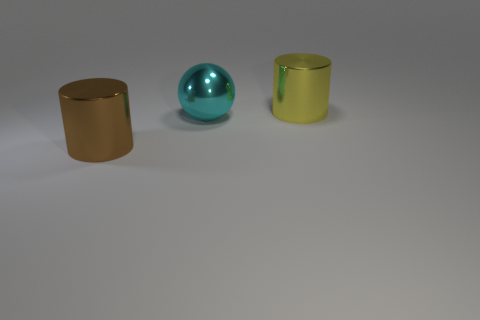How big is the object that is both to the left of the yellow metal object and behind the brown cylinder?
Provide a succinct answer. Large. What is the shape of the big cyan thing that is made of the same material as the brown cylinder?
Your response must be concise. Sphere. Are the big yellow thing and the object on the left side of the cyan metallic ball made of the same material?
Provide a succinct answer. Yes. Are there any big brown things in front of the shiny cylinder left of the large yellow metallic cylinder?
Your answer should be compact. No. There is a brown object that is the same shape as the yellow object; what is its material?
Make the answer very short. Metal. What number of large things are on the right side of the shiny cylinder on the right side of the large cyan sphere?
Provide a short and direct response. 0. Are there any other things of the same color as the shiny sphere?
Your response must be concise. No. How many objects are small gray things or large shiny balls that are to the left of the yellow cylinder?
Keep it short and to the point. 1. What material is the large cylinder to the left of the big thing behind the large sphere that is behind the large brown thing made of?
Provide a short and direct response. Metal. There is a cylinder that is the same material as the brown object; what is its size?
Keep it short and to the point. Large. 